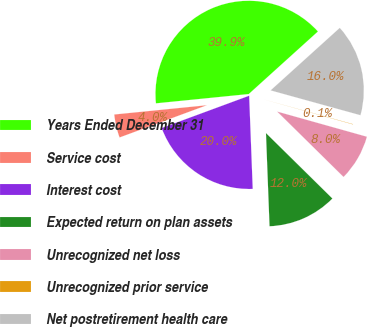<chart> <loc_0><loc_0><loc_500><loc_500><pie_chart><fcel>Years Ended December 31<fcel>Service cost<fcel>Interest cost<fcel>Expected return on plan assets<fcel>Unrecognized net loss<fcel>Unrecognized prior service<fcel>Net postretirement health care<nl><fcel>39.89%<fcel>4.04%<fcel>19.98%<fcel>12.01%<fcel>8.03%<fcel>0.06%<fcel>15.99%<nl></chart> 